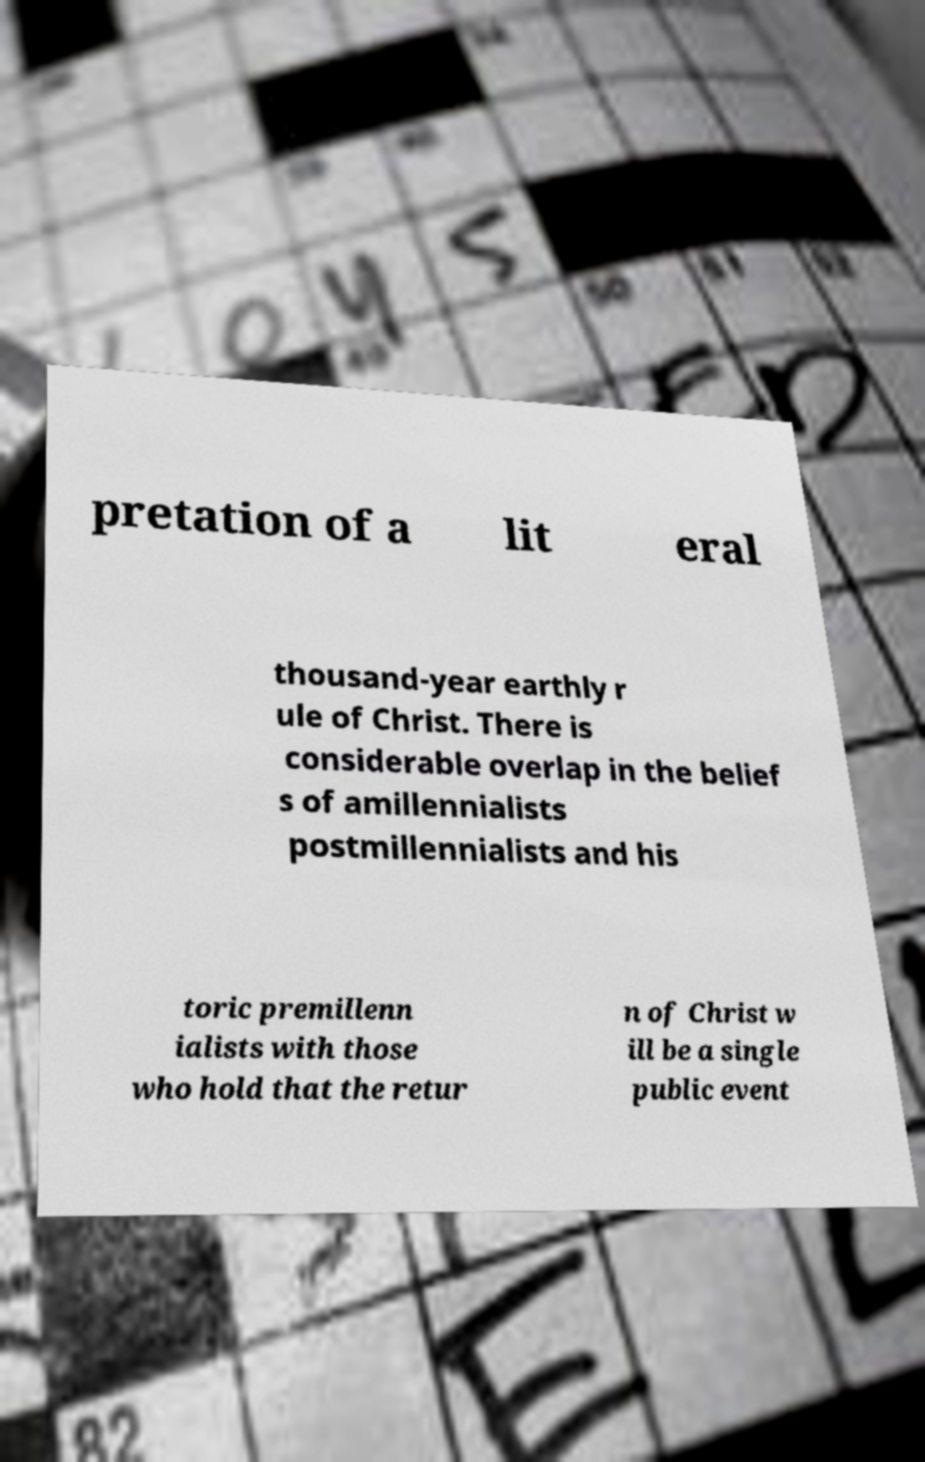Could you extract and type out the text from this image? pretation of a lit eral thousand-year earthly r ule of Christ. There is considerable overlap in the belief s of amillennialists postmillennialists and his toric premillenn ialists with those who hold that the retur n of Christ w ill be a single public event 